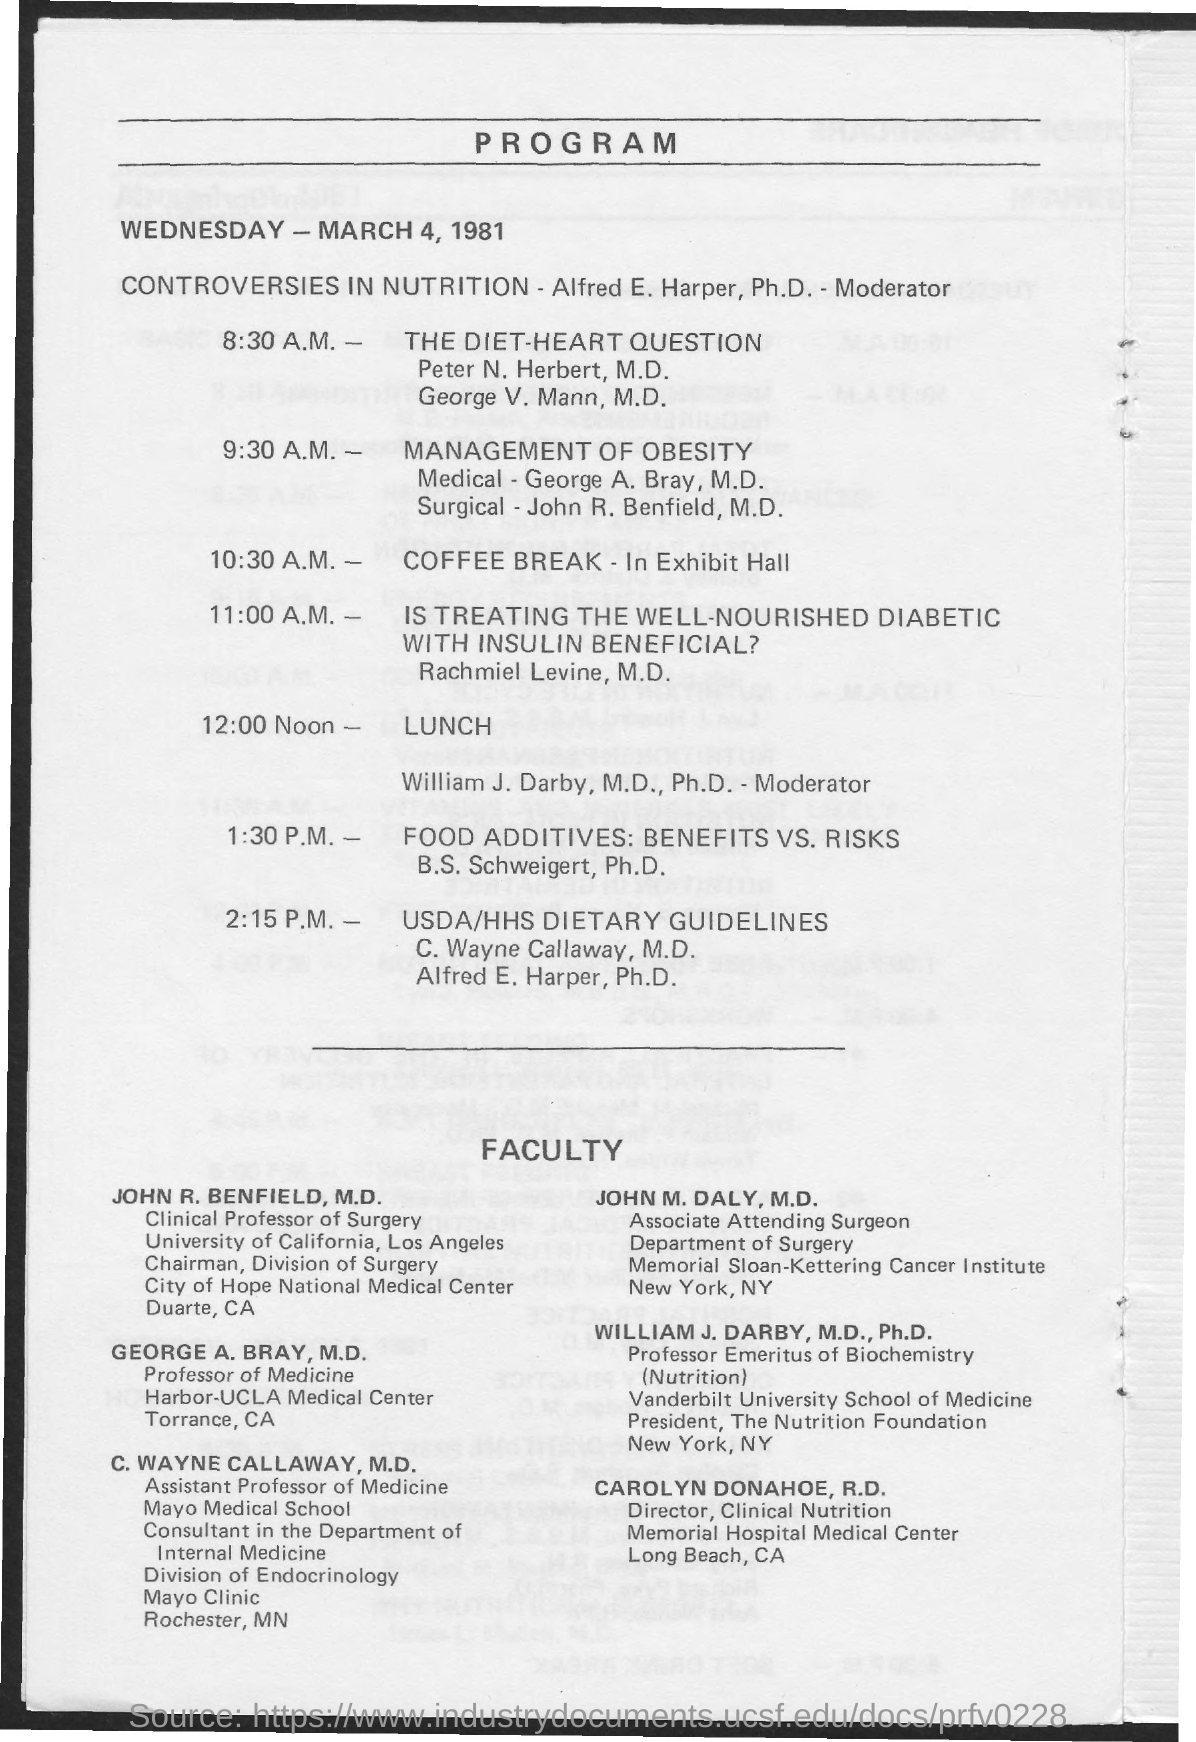Draw attention to some important aspects in this diagram. The location of the coffee break is in the exhibit hall. The coffee break is scheduled for 10:30 A.M. 